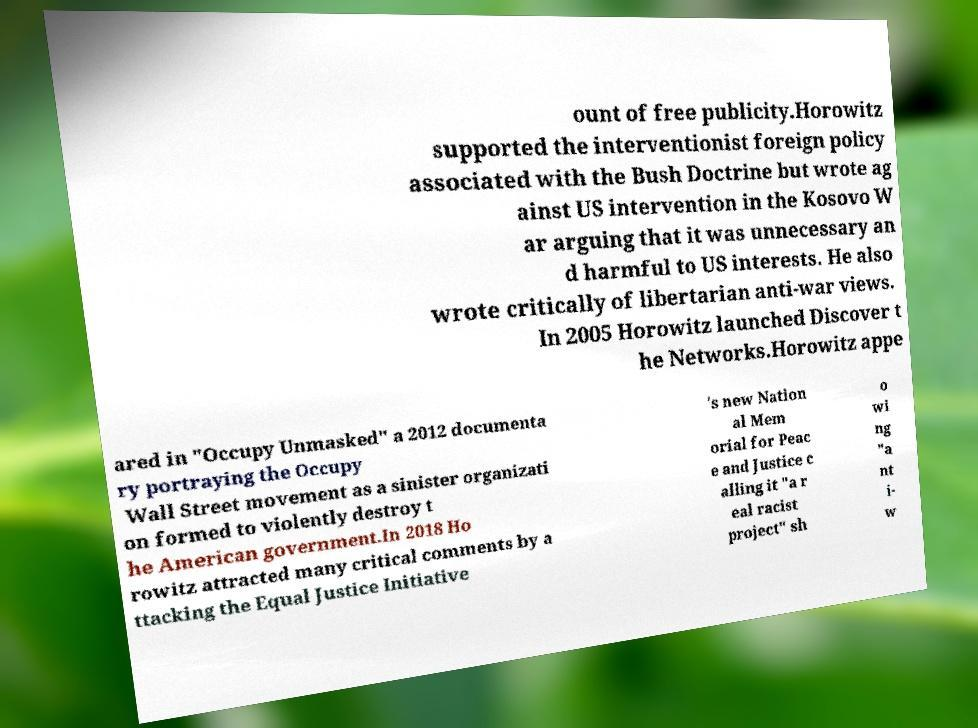There's text embedded in this image that I need extracted. Can you transcribe it verbatim? ount of free publicity.Horowitz supported the interventionist foreign policy associated with the Bush Doctrine but wrote ag ainst US intervention in the Kosovo W ar arguing that it was unnecessary an d harmful to US interests. He also wrote critically of libertarian anti-war views. In 2005 Horowitz launched Discover t he Networks.Horowitz appe ared in "Occupy Unmasked" a 2012 documenta ry portraying the Occupy Wall Street movement as a sinister organizati on formed to violently destroy t he American government.In 2018 Ho rowitz attracted many critical comments by a ttacking the Equal Justice Initiative 's new Nation al Mem orial for Peac e and Justice c alling it "a r eal racist project" sh o wi ng "a nt i- w 